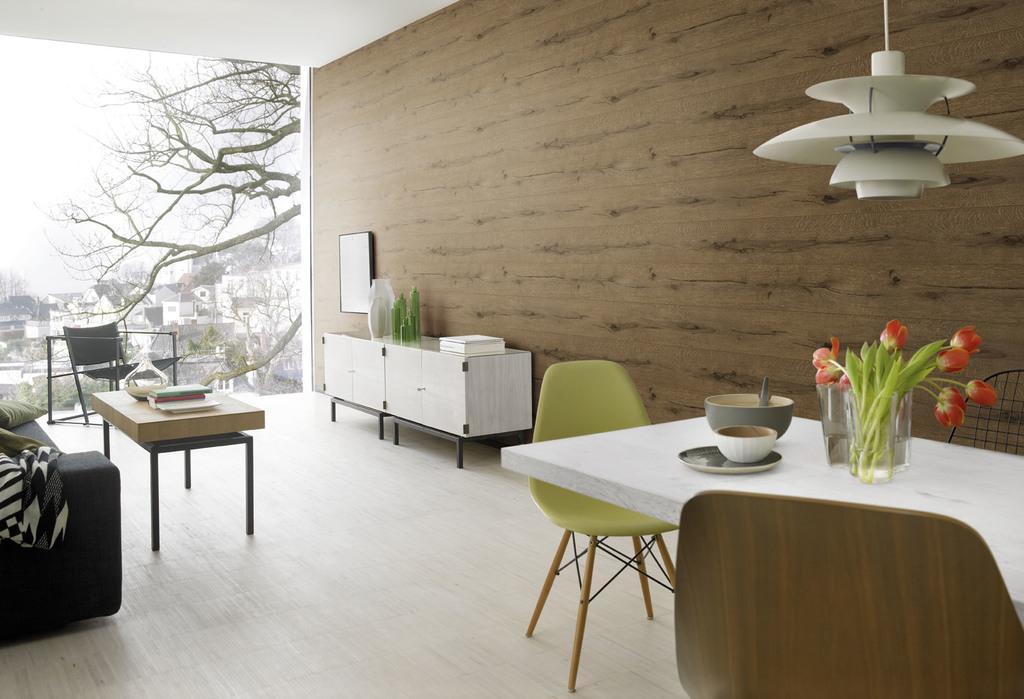Can you describe this image briefly? In this image on the right side there is a table, on the table there are bowls, glass pots, plants and flower and also there are some chairs. And on the left side there is a couch, tables, chairs and on the tables there are some books and some pots. And in the center there is a glass door, through the door we could see some trees and buildings and there is a wall. At the bottom there is floor and at the top there is ceiling, and on the right side of the image there is light. 